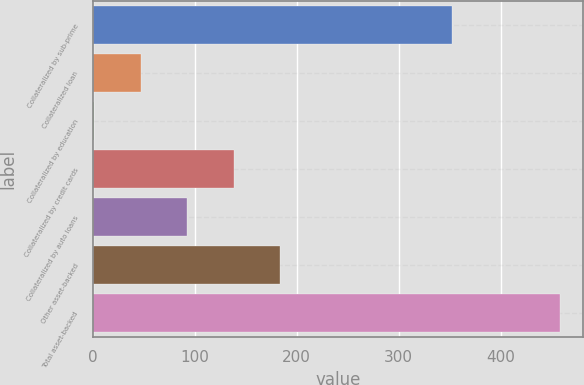Convert chart. <chart><loc_0><loc_0><loc_500><loc_500><bar_chart><fcel>Collateralized by sub-prime<fcel>Collateralized loan<fcel>Collateralized by education<fcel>Collateralized by credit cards<fcel>Collateralized by auto loans<fcel>Other asset-backed<fcel>Total asset-backed<nl><fcel>352<fcel>47.11<fcel>1.46<fcel>138.41<fcel>92.76<fcel>184.06<fcel>458<nl></chart> 